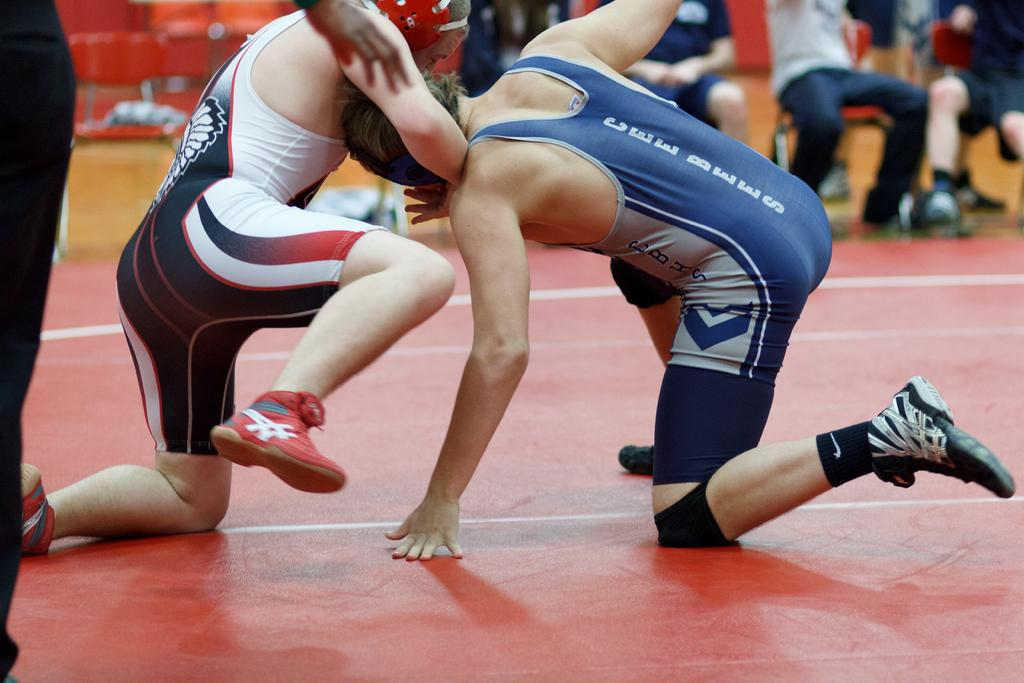<image>
Relay a brief, clear account of the picture shown. A wrestler is wearing a singlet that says CEE BEES down the back. 